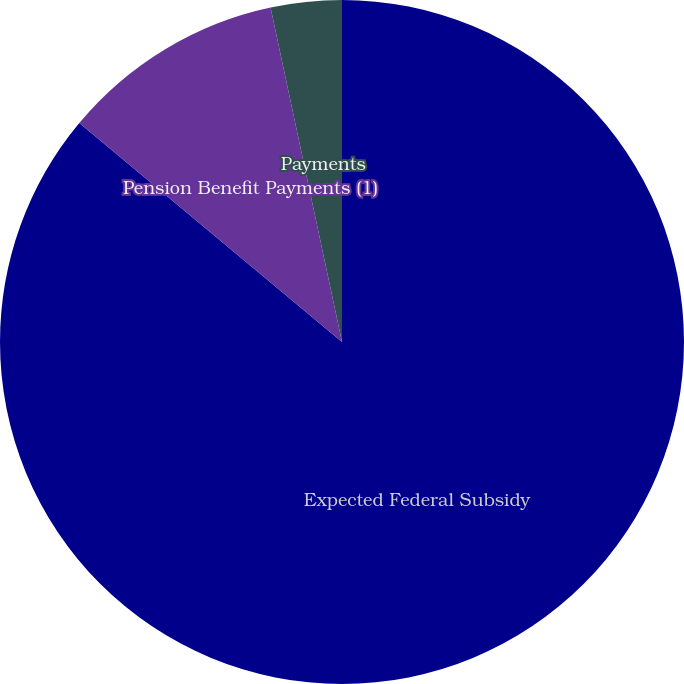<chart> <loc_0><loc_0><loc_500><loc_500><pie_chart><fcel>Expected Federal Subsidy<fcel>Pension Benefit Payments (1)<fcel>Payments<nl><fcel>86.06%<fcel>10.59%<fcel>3.35%<nl></chart> 